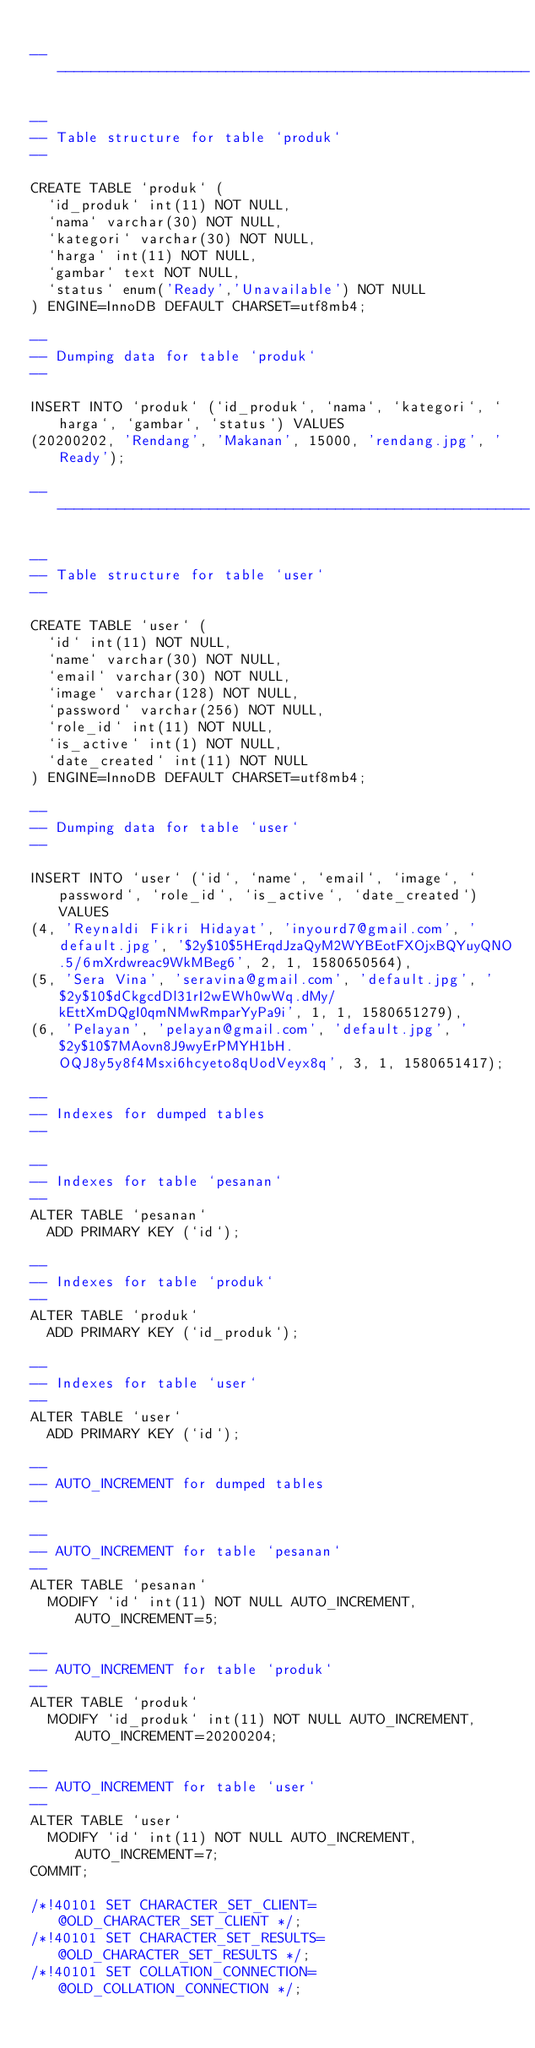<code> <loc_0><loc_0><loc_500><loc_500><_SQL_>
-- --------------------------------------------------------

--
-- Table structure for table `produk`
--

CREATE TABLE `produk` (
  `id_produk` int(11) NOT NULL,
  `nama` varchar(30) NOT NULL,
  `kategori` varchar(30) NOT NULL,
  `harga` int(11) NOT NULL,
  `gambar` text NOT NULL,
  `status` enum('Ready','Unavailable') NOT NULL
) ENGINE=InnoDB DEFAULT CHARSET=utf8mb4;

--
-- Dumping data for table `produk`
--

INSERT INTO `produk` (`id_produk`, `nama`, `kategori`, `harga`, `gambar`, `status`) VALUES
(20200202, 'Rendang', 'Makanan', 15000, 'rendang.jpg', 'Ready');

-- --------------------------------------------------------

--
-- Table structure for table `user`
--

CREATE TABLE `user` (
  `id` int(11) NOT NULL,
  `name` varchar(30) NOT NULL,
  `email` varchar(30) NOT NULL,
  `image` varchar(128) NOT NULL,
  `password` varchar(256) NOT NULL,
  `role_id` int(11) NOT NULL,
  `is_active` int(1) NOT NULL,
  `date_created` int(11) NOT NULL
) ENGINE=InnoDB DEFAULT CHARSET=utf8mb4;

--
-- Dumping data for table `user`
--

INSERT INTO `user` (`id`, `name`, `email`, `image`, `password`, `role_id`, `is_active`, `date_created`) VALUES
(4, 'Reynaldi Fikri Hidayat', 'inyourd7@gmail.com', 'default.jpg', '$2y$10$5HErqdJzaQyM2WYBEotFXOjxBQYuyQNO.5/6mXrdwreac9WkMBeg6', 2, 1, 1580650564),
(5, 'Sera Vina', 'seravina@gmail.com', 'default.jpg', '$2y$10$dCkgcdDl31rI2wEWh0wWq.dMy/kEttXmDQgI0qmNMwRmparYyPa9i', 1, 1, 1580651279),
(6, 'Pelayan', 'pelayan@gmail.com', 'default.jpg', '$2y$10$7MAovn8J9wyErPMYH1bH.OQJ8y5y8f4Msxi6hcyeto8qUodVeyx8q', 3, 1, 1580651417);

--
-- Indexes for dumped tables
--

--
-- Indexes for table `pesanan`
--
ALTER TABLE `pesanan`
  ADD PRIMARY KEY (`id`);

--
-- Indexes for table `produk`
--
ALTER TABLE `produk`
  ADD PRIMARY KEY (`id_produk`);

--
-- Indexes for table `user`
--
ALTER TABLE `user`
  ADD PRIMARY KEY (`id`);

--
-- AUTO_INCREMENT for dumped tables
--

--
-- AUTO_INCREMENT for table `pesanan`
--
ALTER TABLE `pesanan`
  MODIFY `id` int(11) NOT NULL AUTO_INCREMENT, AUTO_INCREMENT=5;

--
-- AUTO_INCREMENT for table `produk`
--
ALTER TABLE `produk`
  MODIFY `id_produk` int(11) NOT NULL AUTO_INCREMENT, AUTO_INCREMENT=20200204;

--
-- AUTO_INCREMENT for table `user`
--
ALTER TABLE `user`
  MODIFY `id` int(11) NOT NULL AUTO_INCREMENT, AUTO_INCREMENT=7;
COMMIT;

/*!40101 SET CHARACTER_SET_CLIENT=@OLD_CHARACTER_SET_CLIENT */;
/*!40101 SET CHARACTER_SET_RESULTS=@OLD_CHARACTER_SET_RESULTS */;
/*!40101 SET COLLATION_CONNECTION=@OLD_COLLATION_CONNECTION */;
</code> 